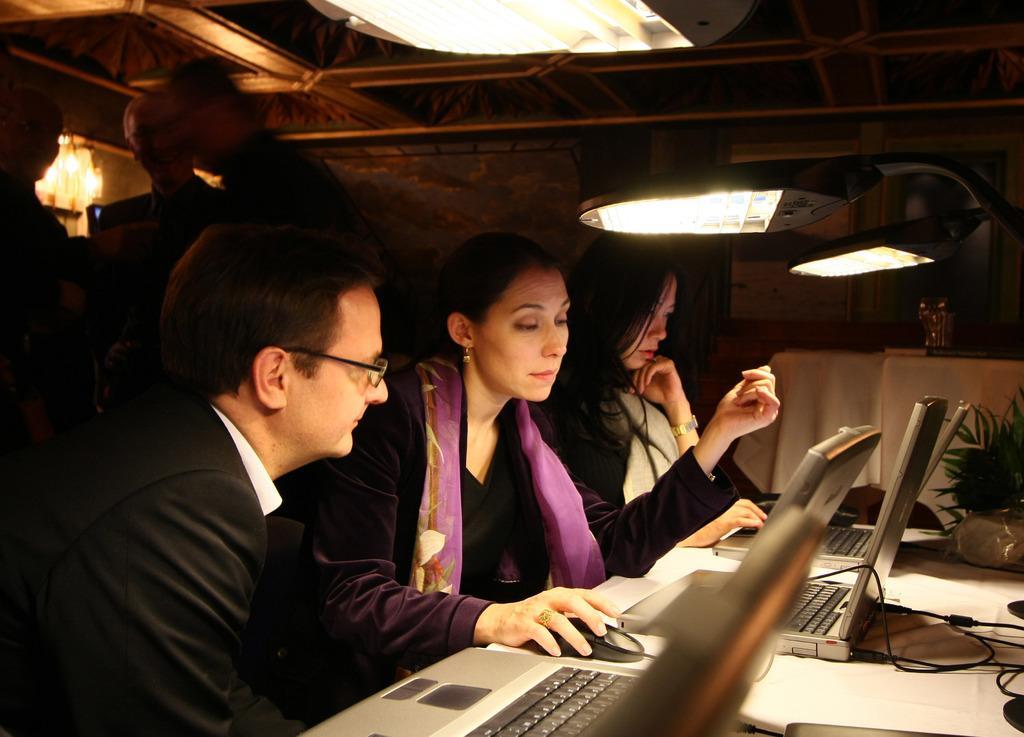Describe this image in one or two sentences. In this picture I can see three people operating laptops. I can see light arrangement on the roof. 